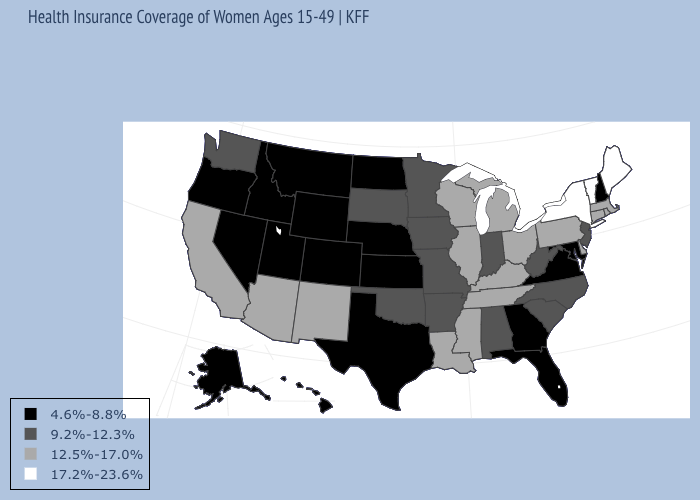What is the value of New Hampshire?
Concise answer only. 4.6%-8.8%. Does Connecticut have a lower value than Maine?
Concise answer only. Yes. Does Missouri have the same value as New Jersey?
Concise answer only. Yes. What is the value of New Mexico?
Concise answer only. 12.5%-17.0%. What is the value of Oklahoma?
Give a very brief answer. 9.2%-12.3%. Does New York have the same value as Maine?
Keep it brief. Yes. What is the value of Utah?
Give a very brief answer. 4.6%-8.8%. Name the states that have a value in the range 4.6%-8.8%?
Keep it brief. Alaska, Colorado, Florida, Georgia, Hawaii, Idaho, Kansas, Maryland, Montana, Nebraska, Nevada, New Hampshire, North Dakota, Oregon, Texas, Utah, Virginia, Wyoming. Name the states that have a value in the range 17.2%-23.6%?
Quick response, please. Maine, New York, Vermont. Which states have the lowest value in the USA?
Quick response, please. Alaska, Colorado, Florida, Georgia, Hawaii, Idaho, Kansas, Maryland, Montana, Nebraska, Nevada, New Hampshire, North Dakota, Oregon, Texas, Utah, Virginia, Wyoming. What is the highest value in states that border Indiana?
Concise answer only. 12.5%-17.0%. What is the lowest value in the USA?
Quick response, please. 4.6%-8.8%. Name the states that have a value in the range 12.5%-17.0%?
Keep it brief. Arizona, California, Connecticut, Delaware, Illinois, Kentucky, Louisiana, Massachusetts, Michigan, Mississippi, New Mexico, Ohio, Pennsylvania, Rhode Island, Tennessee, Wisconsin. Name the states that have a value in the range 12.5%-17.0%?
Concise answer only. Arizona, California, Connecticut, Delaware, Illinois, Kentucky, Louisiana, Massachusetts, Michigan, Mississippi, New Mexico, Ohio, Pennsylvania, Rhode Island, Tennessee, Wisconsin. Is the legend a continuous bar?
Short answer required. No. 